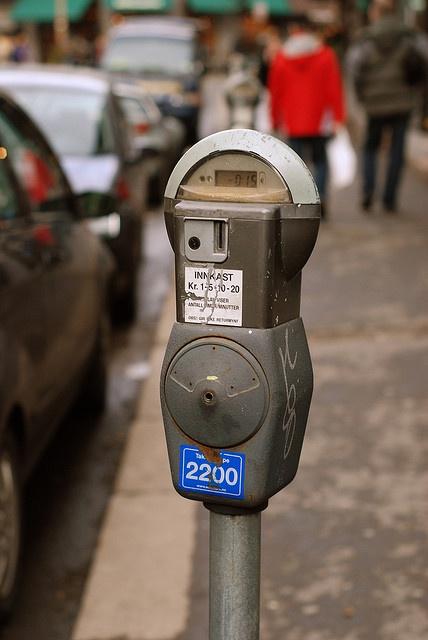Describe the objects in this image and their specific colors. I can see parking meter in black, gray, and darkgray tones, car in black, maroon, and gray tones, car in black, lavender, darkgray, and gray tones, people in black, gray, and maroon tones, and people in black and brown tones in this image. 